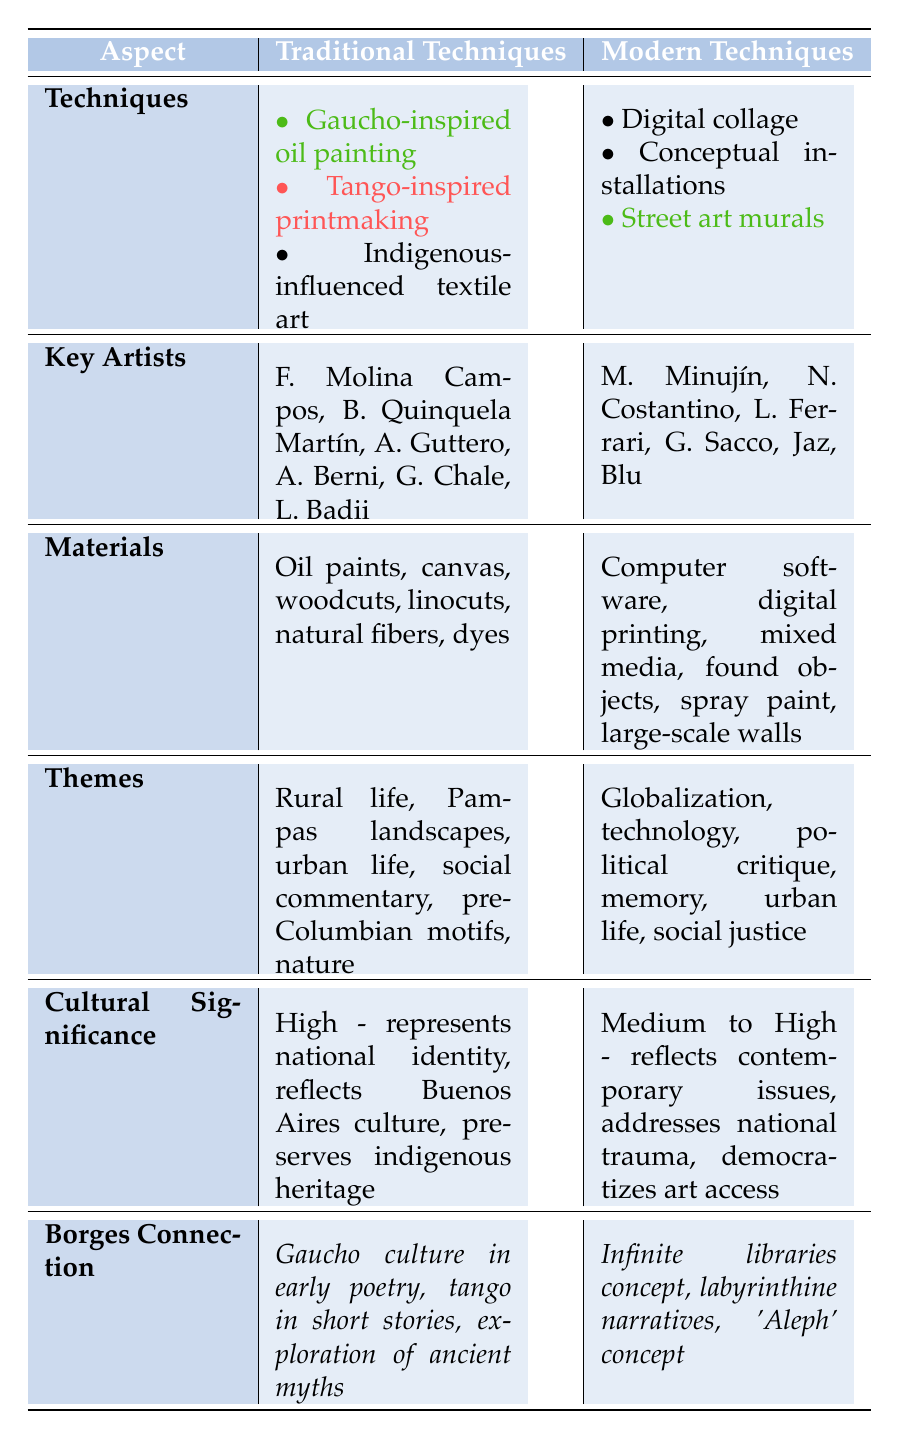What are the key artists associated with Gaucho-inspired oil painting? According to the table, the key artists for Gaucho-inspired oil painting are Florencio Molina Campos and Benito Quinquela Martín.
Answer: Florencio Molina Campos, Benito Quinquela Martín What materials are used in conceptual installations? The table specifies that conceptual installations use mixed media, found objects, and do not list any other specific materials.
Answer: Mixed media, found objects Which technique has the highest cultural significance? Both traditional and modern techniques have high cultural significance, but Indigenous-influenced textile art and conceptual installations are noted as high. Therefore, both fall into this category.
Answer: Indigenous-influenced textile art, conceptual installations Are there any modern techniques that relate to Borges' concept of the 'Aleph'? Yes, the table mentions that street art murals are connected to Borges' 'Aleph' concept.
Answer: Yes How many total techniques are listed for traditional techniques? The table lists three traditional techniques: Gaucho-inspired oil painting, Tango-inspired printmaking, and Indigenous-influenced textile art. Thus, the total count is three.
Answer: 3 Does every modern technique have a cultural significance of at least medium? The table shows that both digital collage and street art murals have medium to high cultural significance, which means that every listed modern technique satisfies the criteria.
Answer: Yes What themes are found in traditional techniques that are related to urban life? The table identifies two themes related to urban life in traditional techniques: urban life and social commentary (found in Tango-inspired printmaking).
Answer: Urban life, social commentary How many key artists are there in total for modern techniques? The table lists six key artists: Marta Minujín, Nicola Costantino, León Ferrari, Graciela Sacco, Jaz, and Blu, resulting in six key artists in total for modern techniques.
Answer: 6 Which traditional technique relates to Borges’ exploration of ancient myths? The table states that Indigenous-influenced textile art relates to Borges' exploration of ancient myths, which connects to Borges' writings.
Answer: Indigenous-influenced textile art 